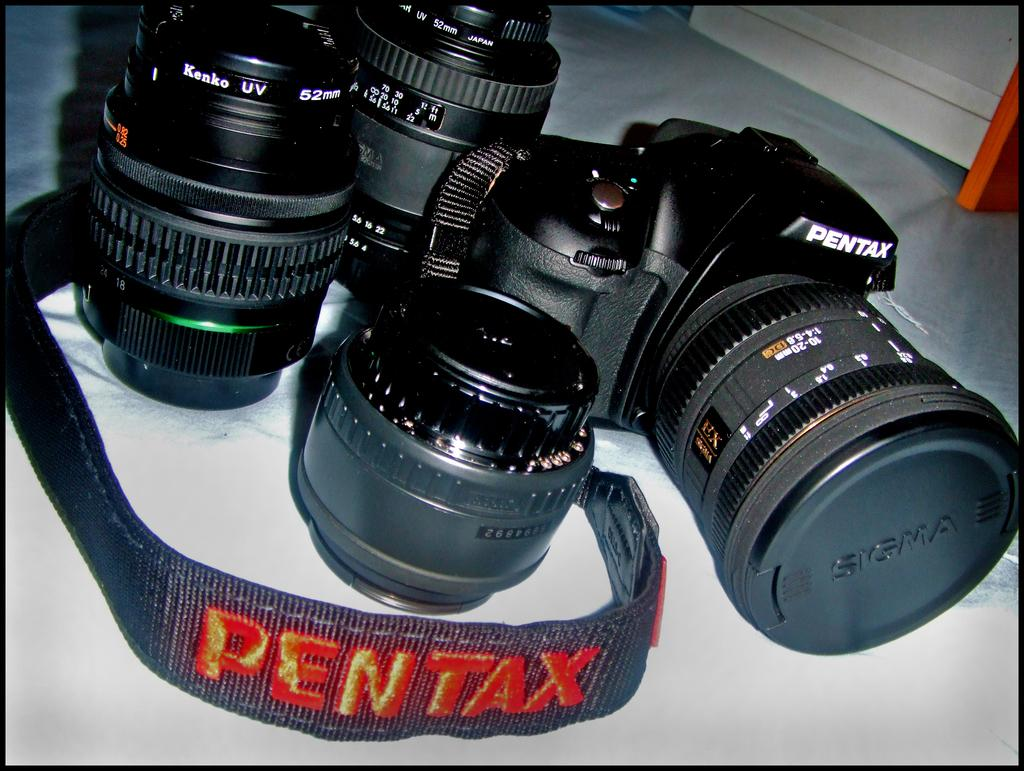What is the main subject of the image? The main subject of the image is a camera. What color is the background of the image? The background of the image is white. What type of silk is being used to create the invention in the image? There is no silk or invention present in the image; it features a camera with a white background. How many pizzas can be seen in the image? There are no pizzas present in the image. 